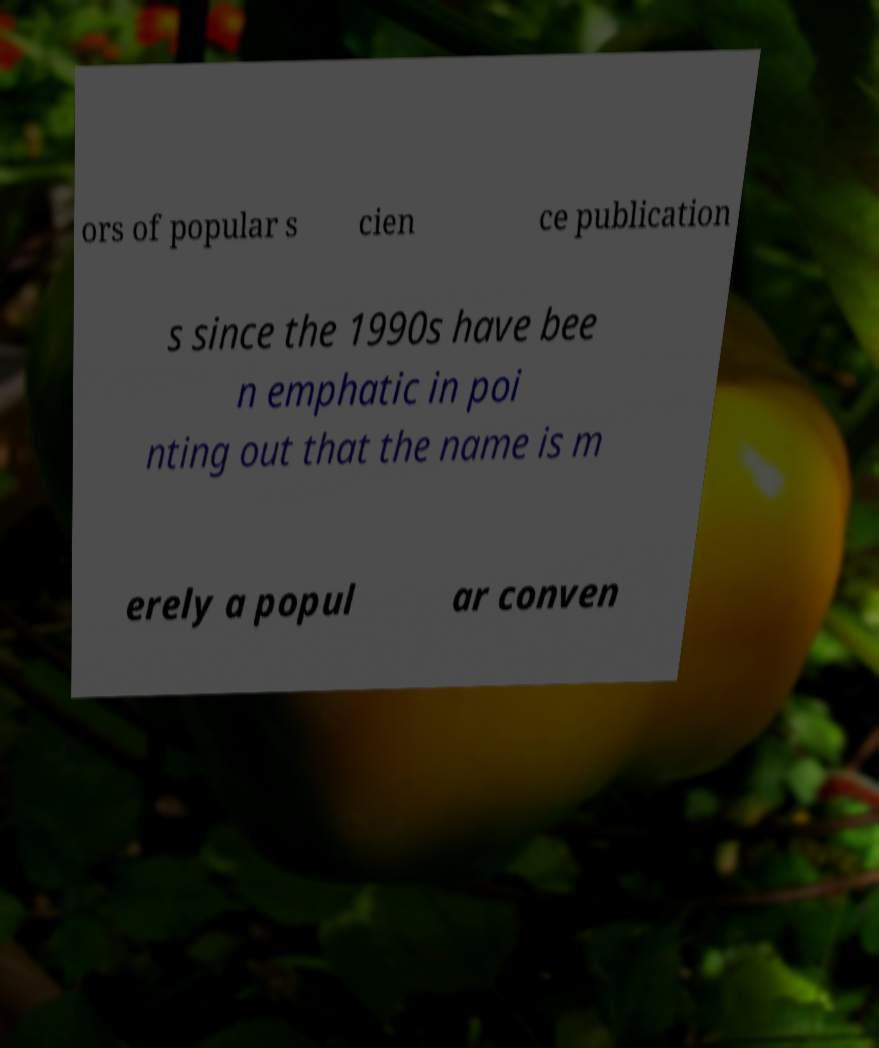For documentation purposes, I need the text within this image transcribed. Could you provide that? ors of popular s cien ce publication s since the 1990s have bee n emphatic in poi nting out that the name is m erely a popul ar conven 